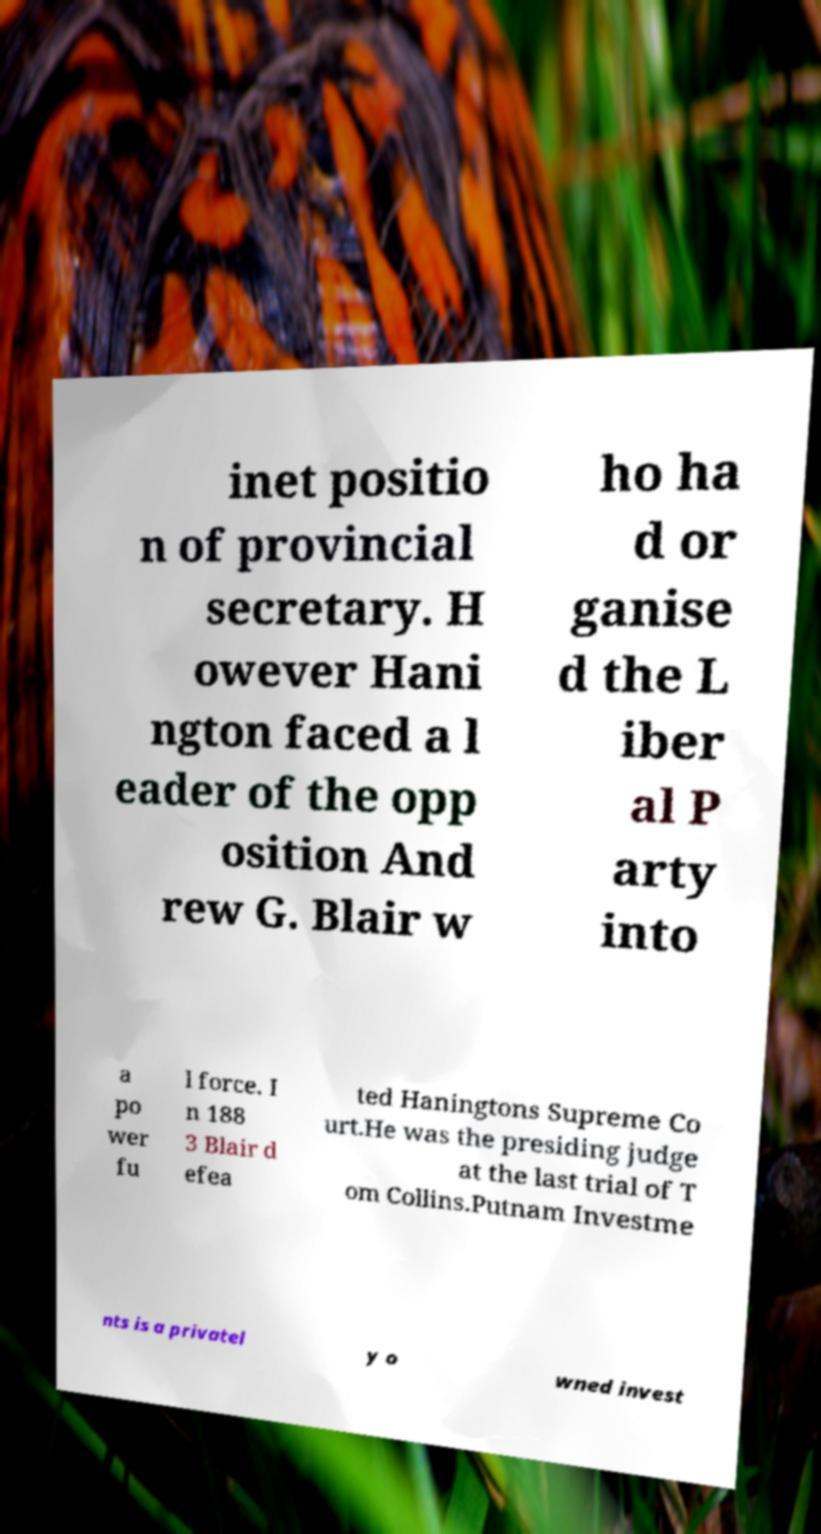Can you read and provide the text displayed in the image?This photo seems to have some interesting text. Can you extract and type it out for me? inet positio n of provincial secretary. H owever Hani ngton faced a l eader of the opp osition And rew G. Blair w ho ha d or ganise d the L iber al P arty into a po wer fu l force. I n 188 3 Blair d efea ted Haningtons Supreme Co urt.He was the presiding judge at the last trial of T om Collins.Putnam Investme nts is a privatel y o wned invest 